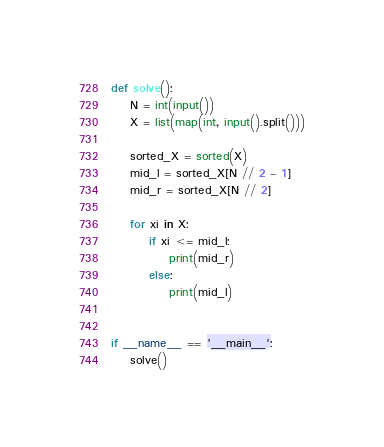Convert code to text. <code><loc_0><loc_0><loc_500><loc_500><_Python_>def solve():
    N = int(input())
    X = list(map(int, input().split()))
    
    sorted_X = sorted(X)
    mid_l = sorted_X[N // 2 - 1]
    mid_r = sorted_X[N // 2]
    
    for xi in X:
        if xi <= mid_l:
            print(mid_r)
        else:
            print(mid_l)


if __name__ == '__main__':
    solve()
</code> 